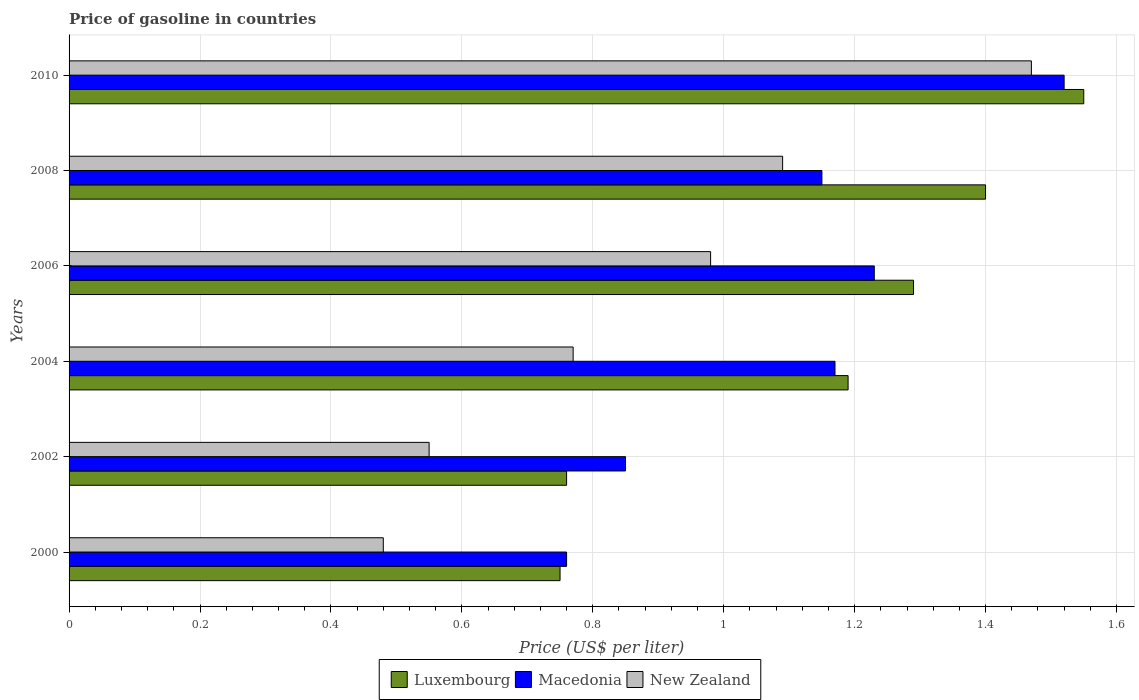How many groups of bars are there?
Ensure brevity in your answer.  6. Are the number of bars per tick equal to the number of legend labels?
Your response must be concise. Yes. Are the number of bars on each tick of the Y-axis equal?
Offer a very short reply. Yes. What is the price of gasoline in Macedonia in 2008?
Your answer should be compact. 1.15. Across all years, what is the maximum price of gasoline in Luxembourg?
Your answer should be compact. 1.55. Across all years, what is the minimum price of gasoline in New Zealand?
Your response must be concise. 0.48. What is the total price of gasoline in Luxembourg in the graph?
Ensure brevity in your answer.  6.94. What is the difference between the price of gasoline in New Zealand in 2002 and that in 2010?
Make the answer very short. -0.92. What is the difference between the price of gasoline in Macedonia in 2008 and the price of gasoline in Luxembourg in 2002?
Provide a succinct answer. 0.39. What is the average price of gasoline in New Zealand per year?
Provide a succinct answer. 0.89. In the year 2008, what is the difference between the price of gasoline in New Zealand and price of gasoline in Macedonia?
Your response must be concise. -0.06. In how many years, is the price of gasoline in Macedonia greater than 0.28 US$?
Provide a short and direct response. 6. What is the ratio of the price of gasoline in New Zealand in 2002 to that in 2008?
Offer a terse response. 0.5. Is the difference between the price of gasoline in New Zealand in 2002 and 2008 greater than the difference between the price of gasoline in Macedonia in 2002 and 2008?
Offer a terse response. No. What is the difference between the highest and the second highest price of gasoline in Macedonia?
Offer a terse response. 0.29. In how many years, is the price of gasoline in New Zealand greater than the average price of gasoline in New Zealand taken over all years?
Provide a short and direct response. 3. What does the 1st bar from the top in 2002 represents?
Ensure brevity in your answer.  New Zealand. What does the 3rd bar from the bottom in 2002 represents?
Your response must be concise. New Zealand. How many bars are there?
Ensure brevity in your answer.  18. Are all the bars in the graph horizontal?
Ensure brevity in your answer.  Yes. How many years are there in the graph?
Ensure brevity in your answer.  6. What is the difference between two consecutive major ticks on the X-axis?
Give a very brief answer. 0.2. Are the values on the major ticks of X-axis written in scientific E-notation?
Keep it short and to the point. No. How are the legend labels stacked?
Your response must be concise. Horizontal. What is the title of the graph?
Offer a very short reply. Price of gasoline in countries. What is the label or title of the X-axis?
Your answer should be very brief. Price (US$ per liter). What is the label or title of the Y-axis?
Keep it short and to the point. Years. What is the Price (US$ per liter) of Luxembourg in 2000?
Provide a short and direct response. 0.75. What is the Price (US$ per liter) of Macedonia in 2000?
Provide a succinct answer. 0.76. What is the Price (US$ per liter) in New Zealand in 2000?
Provide a short and direct response. 0.48. What is the Price (US$ per liter) of Luxembourg in 2002?
Keep it short and to the point. 0.76. What is the Price (US$ per liter) of Macedonia in 2002?
Your answer should be very brief. 0.85. What is the Price (US$ per liter) in New Zealand in 2002?
Your answer should be very brief. 0.55. What is the Price (US$ per liter) of Luxembourg in 2004?
Offer a very short reply. 1.19. What is the Price (US$ per liter) of Macedonia in 2004?
Make the answer very short. 1.17. What is the Price (US$ per liter) of New Zealand in 2004?
Ensure brevity in your answer.  0.77. What is the Price (US$ per liter) of Luxembourg in 2006?
Provide a succinct answer. 1.29. What is the Price (US$ per liter) in Macedonia in 2006?
Give a very brief answer. 1.23. What is the Price (US$ per liter) of New Zealand in 2006?
Give a very brief answer. 0.98. What is the Price (US$ per liter) in Macedonia in 2008?
Give a very brief answer. 1.15. What is the Price (US$ per liter) in New Zealand in 2008?
Ensure brevity in your answer.  1.09. What is the Price (US$ per liter) of Luxembourg in 2010?
Make the answer very short. 1.55. What is the Price (US$ per liter) of Macedonia in 2010?
Your response must be concise. 1.52. What is the Price (US$ per liter) in New Zealand in 2010?
Keep it short and to the point. 1.47. Across all years, what is the maximum Price (US$ per liter) of Luxembourg?
Your response must be concise. 1.55. Across all years, what is the maximum Price (US$ per liter) in Macedonia?
Offer a very short reply. 1.52. Across all years, what is the maximum Price (US$ per liter) of New Zealand?
Your answer should be compact. 1.47. Across all years, what is the minimum Price (US$ per liter) of Luxembourg?
Offer a terse response. 0.75. Across all years, what is the minimum Price (US$ per liter) of Macedonia?
Your answer should be compact. 0.76. Across all years, what is the minimum Price (US$ per liter) of New Zealand?
Provide a short and direct response. 0.48. What is the total Price (US$ per liter) in Luxembourg in the graph?
Keep it short and to the point. 6.94. What is the total Price (US$ per liter) in Macedonia in the graph?
Your answer should be very brief. 6.68. What is the total Price (US$ per liter) in New Zealand in the graph?
Your response must be concise. 5.34. What is the difference between the Price (US$ per liter) of Luxembourg in 2000 and that in 2002?
Give a very brief answer. -0.01. What is the difference between the Price (US$ per liter) of Macedonia in 2000 and that in 2002?
Provide a succinct answer. -0.09. What is the difference between the Price (US$ per liter) of New Zealand in 2000 and that in 2002?
Your answer should be compact. -0.07. What is the difference between the Price (US$ per liter) of Luxembourg in 2000 and that in 2004?
Your answer should be compact. -0.44. What is the difference between the Price (US$ per liter) of Macedonia in 2000 and that in 2004?
Provide a short and direct response. -0.41. What is the difference between the Price (US$ per liter) of New Zealand in 2000 and that in 2004?
Your answer should be very brief. -0.29. What is the difference between the Price (US$ per liter) of Luxembourg in 2000 and that in 2006?
Provide a short and direct response. -0.54. What is the difference between the Price (US$ per liter) in Macedonia in 2000 and that in 2006?
Your answer should be compact. -0.47. What is the difference between the Price (US$ per liter) of New Zealand in 2000 and that in 2006?
Offer a very short reply. -0.5. What is the difference between the Price (US$ per liter) of Luxembourg in 2000 and that in 2008?
Your response must be concise. -0.65. What is the difference between the Price (US$ per liter) in Macedonia in 2000 and that in 2008?
Your answer should be very brief. -0.39. What is the difference between the Price (US$ per liter) in New Zealand in 2000 and that in 2008?
Provide a succinct answer. -0.61. What is the difference between the Price (US$ per liter) of Macedonia in 2000 and that in 2010?
Make the answer very short. -0.76. What is the difference between the Price (US$ per liter) of New Zealand in 2000 and that in 2010?
Offer a terse response. -0.99. What is the difference between the Price (US$ per liter) of Luxembourg in 2002 and that in 2004?
Make the answer very short. -0.43. What is the difference between the Price (US$ per liter) of Macedonia in 2002 and that in 2004?
Keep it short and to the point. -0.32. What is the difference between the Price (US$ per liter) in New Zealand in 2002 and that in 2004?
Keep it short and to the point. -0.22. What is the difference between the Price (US$ per liter) in Luxembourg in 2002 and that in 2006?
Your response must be concise. -0.53. What is the difference between the Price (US$ per liter) in Macedonia in 2002 and that in 2006?
Give a very brief answer. -0.38. What is the difference between the Price (US$ per liter) of New Zealand in 2002 and that in 2006?
Offer a terse response. -0.43. What is the difference between the Price (US$ per liter) in Luxembourg in 2002 and that in 2008?
Offer a terse response. -0.64. What is the difference between the Price (US$ per liter) of Macedonia in 2002 and that in 2008?
Offer a terse response. -0.3. What is the difference between the Price (US$ per liter) in New Zealand in 2002 and that in 2008?
Provide a short and direct response. -0.54. What is the difference between the Price (US$ per liter) of Luxembourg in 2002 and that in 2010?
Your answer should be very brief. -0.79. What is the difference between the Price (US$ per liter) of Macedonia in 2002 and that in 2010?
Provide a short and direct response. -0.67. What is the difference between the Price (US$ per liter) in New Zealand in 2002 and that in 2010?
Your response must be concise. -0.92. What is the difference between the Price (US$ per liter) in Luxembourg in 2004 and that in 2006?
Give a very brief answer. -0.1. What is the difference between the Price (US$ per liter) of Macedonia in 2004 and that in 2006?
Your response must be concise. -0.06. What is the difference between the Price (US$ per liter) of New Zealand in 2004 and that in 2006?
Your response must be concise. -0.21. What is the difference between the Price (US$ per liter) in Luxembourg in 2004 and that in 2008?
Your response must be concise. -0.21. What is the difference between the Price (US$ per liter) of New Zealand in 2004 and that in 2008?
Your answer should be compact. -0.32. What is the difference between the Price (US$ per liter) in Luxembourg in 2004 and that in 2010?
Provide a short and direct response. -0.36. What is the difference between the Price (US$ per liter) of Macedonia in 2004 and that in 2010?
Provide a short and direct response. -0.35. What is the difference between the Price (US$ per liter) of New Zealand in 2004 and that in 2010?
Your answer should be compact. -0.7. What is the difference between the Price (US$ per liter) of Luxembourg in 2006 and that in 2008?
Offer a terse response. -0.11. What is the difference between the Price (US$ per liter) in New Zealand in 2006 and that in 2008?
Offer a very short reply. -0.11. What is the difference between the Price (US$ per liter) of Luxembourg in 2006 and that in 2010?
Your answer should be very brief. -0.26. What is the difference between the Price (US$ per liter) of Macedonia in 2006 and that in 2010?
Your answer should be very brief. -0.29. What is the difference between the Price (US$ per liter) of New Zealand in 2006 and that in 2010?
Offer a terse response. -0.49. What is the difference between the Price (US$ per liter) in Macedonia in 2008 and that in 2010?
Offer a very short reply. -0.37. What is the difference between the Price (US$ per liter) in New Zealand in 2008 and that in 2010?
Your answer should be very brief. -0.38. What is the difference between the Price (US$ per liter) in Luxembourg in 2000 and the Price (US$ per liter) in Macedonia in 2002?
Give a very brief answer. -0.1. What is the difference between the Price (US$ per liter) of Macedonia in 2000 and the Price (US$ per liter) of New Zealand in 2002?
Provide a succinct answer. 0.21. What is the difference between the Price (US$ per liter) in Luxembourg in 2000 and the Price (US$ per liter) in Macedonia in 2004?
Provide a succinct answer. -0.42. What is the difference between the Price (US$ per liter) of Luxembourg in 2000 and the Price (US$ per liter) of New Zealand in 2004?
Provide a short and direct response. -0.02. What is the difference between the Price (US$ per liter) in Macedonia in 2000 and the Price (US$ per liter) in New Zealand in 2004?
Your response must be concise. -0.01. What is the difference between the Price (US$ per liter) in Luxembourg in 2000 and the Price (US$ per liter) in Macedonia in 2006?
Offer a very short reply. -0.48. What is the difference between the Price (US$ per liter) of Luxembourg in 2000 and the Price (US$ per liter) of New Zealand in 2006?
Make the answer very short. -0.23. What is the difference between the Price (US$ per liter) in Macedonia in 2000 and the Price (US$ per liter) in New Zealand in 2006?
Give a very brief answer. -0.22. What is the difference between the Price (US$ per liter) in Luxembourg in 2000 and the Price (US$ per liter) in Macedonia in 2008?
Give a very brief answer. -0.4. What is the difference between the Price (US$ per liter) of Luxembourg in 2000 and the Price (US$ per liter) of New Zealand in 2008?
Your response must be concise. -0.34. What is the difference between the Price (US$ per liter) of Macedonia in 2000 and the Price (US$ per liter) of New Zealand in 2008?
Make the answer very short. -0.33. What is the difference between the Price (US$ per liter) in Luxembourg in 2000 and the Price (US$ per liter) in Macedonia in 2010?
Your answer should be very brief. -0.77. What is the difference between the Price (US$ per liter) in Luxembourg in 2000 and the Price (US$ per liter) in New Zealand in 2010?
Your answer should be compact. -0.72. What is the difference between the Price (US$ per liter) of Macedonia in 2000 and the Price (US$ per liter) of New Zealand in 2010?
Offer a terse response. -0.71. What is the difference between the Price (US$ per liter) in Luxembourg in 2002 and the Price (US$ per liter) in Macedonia in 2004?
Offer a terse response. -0.41. What is the difference between the Price (US$ per liter) in Luxembourg in 2002 and the Price (US$ per liter) in New Zealand in 2004?
Offer a very short reply. -0.01. What is the difference between the Price (US$ per liter) in Macedonia in 2002 and the Price (US$ per liter) in New Zealand in 2004?
Your answer should be compact. 0.08. What is the difference between the Price (US$ per liter) in Luxembourg in 2002 and the Price (US$ per liter) in Macedonia in 2006?
Offer a very short reply. -0.47. What is the difference between the Price (US$ per liter) in Luxembourg in 2002 and the Price (US$ per liter) in New Zealand in 2006?
Give a very brief answer. -0.22. What is the difference between the Price (US$ per liter) of Macedonia in 2002 and the Price (US$ per liter) of New Zealand in 2006?
Provide a short and direct response. -0.13. What is the difference between the Price (US$ per liter) in Luxembourg in 2002 and the Price (US$ per liter) in Macedonia in 2008?
Offer a very short reply. -0.39. What is the difference between the Price (US$ per liter) of Luxembourg in 2002 and the Price (US$ per liter) of New Zealand in 2008?
Ensure brevity in your answer.  -0.33. What is the difference between the Price (US$ per liter) of Macedonia in 2002 and the Price (US$ per liter) of New Zealand in 2008?
Give a very brief answer. -0.24. What is the difference between the Price (US$ per liter) in Luxembourg in 2002 and the Price (US$ per liter) in Macedonia in 2010?
Ensure brevity in your answer.  -0.76. What is the difference between the Price (US$ per liter) of Luxembourg in 2002 and the Price (US$ per liter) of New Zealand in 2010?
Your response must be concise. -0.71. What is the difference between the Price (US$ per liter) in Macedonia in 2002 and the Price (US$ per liter) in New Zealand in 2010?
Offer a terse response. -0.62. What is the difference between the Price (US$ per liter) in Luxembourg in 2004 and the Price (US$ per liter) in Macedonia in 2006?
Offer a terse response. -0.04. What is the difference between the Price (US$ per liter) in Luxembourg in 2004 and the Price (US$ per liter) in New Zealand in 2006?
Your answer should be very brief. 0.21. What is the difference between the Price (US$ per liter) in Macedonia in 2004 and the Price (US$ per liter) in New Zealand in 2006?
Ensure brevity in your answer.  0.19. What is the difference between the Price (US$ per liter) in Luxembourg in 2004 and the Price (US$ per liter) in Macedonia in 2008?
Keep it short and to the point. 0.04. What is the difference between the Price (US$ per liter) of Luxembourg in 2004 and the Price (US$ per liter) of New Zealand in 2008?
Offer a terse response. 0.1. What is the difference between the Price (US$ per liter) in Luxembourg in 2004 and the Price (US$ per liter) in Macedonia in 2010?
Your answer should be compact. -0.33. What is the difference between the Price (US$ per liter) in Luxembourg in 2004 and the Price (US$ per liter) in New Zealand in 2010?
Ensure brevity in your answer.  -0.28. What is the difference between the Price (US$ per liter) of Macedonia in 2004 and the Price (US$ per liter) of New Zealand in 2010?
Provide a short and direct response. -0.3. What is the difference between the Price (US$ per liter) in Luxembourg in 2006 and the Price (US$ per liter) in Macedonia in 2008?
Keep it short and to the point. 0.14. What is the difference between the Price (US$ per liter) in Macedonia in 2006 and the Price (US$ per liter) in New Zealand in 2008?
Your response must be concise. 0.14. What is the difference between the Price (US$ per liter) in Luxembourg in 2006 and the Price (US$ per liter) in Macedonia in 2010?
Ensure brevity in your answer.  -0.23. What is the difference between the Price (US$ per liter) of Luxembourg in 2006 and the Price (US$ per liter) of New Zealand in 2010?
Your answer should be very brief. -0.18. What is the difference between the Price (US$ per liter) of Macedonia in 2006 and the Price (US$ per liter) of New Zealand in 2010?
Offer a very short reply. -0.24. What is the difference between the Price (US$ per liter) of Luxembourg in 2008 and the Price (US$ per liter) of Macedonia in 2010?
Make the answer very short. -0.12. What is the difference between the Price (US$ per liter) of Luxembourg in 2008 and the Price (US$ per liter) of New Zealand in 2010?
Provide a short and direct response. -0.07. What is the difference between the Price (US$ per liter) of Macedonia in 2008 and the Price (US$ per liter) of New Zealand in 2010?
Provide a short and direct response. -0.32. What is the average Price (US$ per liter) in Luxembourg per year?
Your response must be concise. 1.16. What is the average Price (US$ per liter) of Macedonia per year?
Give a very brief answer. 1.11. What is the average Price (US$ per liter) of New Zealand per year?
Offer a terse response. 0.89. In the year 2000, what is the difference between the Price (US$ per liter) in Luxembourg and Price (US$ per liter) in Macedonia?
Offer a very short reply. -0.01. In the year 2000, what is the difference between the Price (US$ per liter) in Luxembourg and Price (US$ per liter) in New Zealand?
Give a very brief answer. 0.27. In the year 2000, what is the difference between the Price (US$ per liter) in Macedonia and Price (US$ per liter) in New Zealand?
Keep it short and to the point. 0.28. In the year 2002, what is the difference between the Price (US$ per liter) of Luxembourg and Price (US$ per liter) of Macedonia?
Your response must be concise. -0.09. In the year 2002, what is the difference between the Price (US$ per liter) in Luxembourg and Price (US$ per liter) in New Zealand?
Your answer should be compact. 0.21. In the year 2004, what is the difference between the Price (US$ per liter) in Luxembourg and Price (US$ per liter) in Macedonia?
Make the answer very short. 0.02. In the year 2004, what is the difference between the Price (US$ per liter) of Luxembourg and Price (US$ per liter) of New Zealand?
Your answer should be compact. 0.42. In the year 2006, what is the difference between the Price (US$ per liter) in Luxembourg and Price (US$ per liter) in Macedonia?
Your answer should be compact. 0.06. In the year 2006, what is the difference between the Price (US$ per liter) of Luxembourg and Price (US$ per liter) of New Zealand?
Your answer should be very brief. 0.31. In the year 2006, what is the difference between the Price (US$ per liter) of Macedonia and Price (US$ per liter) of New Zealand?
Your answer should be very brief. 0.25. In the year 2008, what is the difference between the Price (US$ per liter) in Luxembourg and Price (US$ per liter) in Macedonia?
Give a very brief answer. 0.25. In the year 2008, what is the difference between the Price (US$ per liter) of Luxembourg and Price (US$ per liter) of New Zealand?
Your answer should be very brief. 0.31. In the year 2008, what is the difference between the Price (US$ per liter) of Macedonia and Price (US$ per liter) of New Zealand?
Your answer should be compact. 0.06. In the year 2010, what is the difference between the Price (US$ per liter) in Luxembourg and Price (US$ per liter) in Macedonia?
Provide a short and direct response. 0.03. In the year 2010, what is the difference between the Price (US$ per liter) in Macedonia and Price (US$ per liter) in New Zealand?
Ensure brevity in your answer.  0.05. What is the ratio of the Price (US$ per liter) in Luxembourg in 2000 to that in 2002?
Your answer should be very brief. 0.99. What is the ratio of the Price (US$ per liter) of Macedonia in 2000 to that in 2002?
Offer a terse response. 0.89. What is the ratio of the Price (US$ per liter) of New Zealand in 2000 to that in 2002?
Ensure brevity in your answer.  0.87. What is the ratio of the Price (US$ per liter) in Luxembourg in 2000 to that in 2004?
Keep it short and to the point. 0.63. What is the ratio of the Price (US$ per liter) of Macedonia in 2000 to that in 2004?
Offer a terse response. 0.65. What is the ratio of the Price (US$ per liter) of New Zealand in 2000 to that in 2004?
Provide a short and direct response. 0.62. What is the ratio of the Price (US$ per liter) in Luxembourg in 2000 to that in 2006?
Keep it short and to the point. 0.58. What is the ratio of the Price (US$ per liter) in Macedonia in 2000 to that in 2006?
Make the answer very short. 0.62. What is the ratio of the Price (US$ per liter) of New Zealand in 2000 to that in 2006?
Provide a succinct answer. 0.49. What is the ratio of the Price (US$ per liter) of Luxembourg in 2000 to that in 2008?
Provide a short and direct response. 0.54. What is the ratio of the Price (US$ per liter) in Macedonia in 2000 to that in 2008?
Offer a very short reply. 0.66. What is the ratio of the Price (US$ per liter) in New Zealand in 2000 to that in 2008?
Your answer should be very brief. 0.44. What is the ratio of the Price (US$ per liter) in Luxembourg in 2000 to that in 2010?
Your response must be concise. 0.48. What is the ratio of the Price (US$ per liter) in New Zealand in 2000 to that in 2010?
Give a very brief answer. 0.33. What is the ratio of the Price (US$ per liter) in Luxembourg in 2002 to that in 2004?
Keep it short and to the point. 0.64. What is the ratio of the Price (US$ per liter) in Macedonia in 2002 to that in 2004?
Provide a succinct answer. 0.73. What is the ratio of the Price (US$ per liter) in Luxembourg in 2002 to that in 2006?
Make the answer very short. 0.59. What is the ratio of the Price (US$ per liter) of Macedonia in 2002 to that in 2006?
Offer a terse response. 0.69. What is the ratio of the Price (US$ per liter) in New Zealand in 2002 to that in 2006?
Provide a succinct answer. 0.56. What is the ratio of the Price (US$ per liter) of Luxembourg in 2002 to that in 2008?
Offer a very short reply. 0.54. What is the ratio of the Price (US$ per liter) in Macedonia in 2002 to that in 2008?
Provide a short and direct response. 0.74. What is the ratio of the Price (US$ per liter) in New Zealand in 2002 to that in 2008?
Provide a short and direct response. 0.5. What is the ratio of the Price (US$ per liter) of Luxembourg in 2002 to that in 2010?
Your answer should be very brief. 0.49. What is the ratio of the Price (US$ per liter) in Macedonia in 2002 to that in 2010?
Your response must be concise. 0.56. What is the ratio of the Price (US$ per liter) in New Zealand in 2002 to that in 2010?
Provide a succinct answer. 0.37. What is the ratio of the Price (US$ per liter) of Luxembourg in 2004 to that in 2006?
Ensure brevity in your answer.  0.92. What is the ratio of the Price (US$ per liter) of Macedonia in 2004 to that in 2006?
Give a very brief answer. 0.95. What is the ratio of the Price (US$ per liter) of New Zealand in 2004 to that in 2006?
Give a very brief answer. 0.79. What is the ratio of the Price (US$ per liter) of Macedonia in 2004 to that in 2008?
Ensure brevity in your answer.  1.02. What is the ratio of the Price (US$ per liter) in New Zealand in 2004 to that in 2008?
Ensure brevity in your answer.  0.71. What is the ratio of the Price (US$ per liter) in Luxembourg in 2004 to that in 2010?
Provide a short and direct response. 0.77. What is the ratio of the Price (US$ per liter) in Macedonia in 2004 to that in 2010?
Offer a very short reply. 0.77. What is the ratio of the Price (US$ per liter) in New Zealand in 2004 to that in 2010?
Provide a short and direct response. 0.52. What is the ratio of the Price (US$ per liter) in Luxembourg in 2006 to that in 2008?
Your answer should be very brief. 0.92. What is the ratio of the Price (US$ per liter) of Macedonia in 2006 to that in 2008?
Your answer should be very brief. 1.07. What is the ratio of the Price (US$ per liter) in New Zealand in 2006 to that in 2008?
Your answer should be very brief. 0.9. What is the ratio of the Price (US$ per liter) of Luxembourg in 2006 to that in 2010?
Make the answer very short. 0.83. What is the ratio of the Price (US$ per liter) of Macedonia in 2006 to that in 2010?
Keep it short and to the point. 0.81. What is the ratio of the Price (US$ per liter) in New Zealand in 2006 to that in 2010?
Provide a succinct answer. 0.67. What is the ratio of the Price (US$ per liter) in Luxembourg in 2008 to that in 2010?
Provide a succinct answer. 0.9. What is the ratio of the Price (US$ per liter) of Macedonia in 2008 to that in 2010?
Provide a succinct answer. 0.76. What is the ratio of the Price (US$ per liter) of New Zealand in 2008 to that in 2010?
Your answer should be compact. 0.74. What is the difference between the highest and the second highest Price (US$ per liter) in Macedonia?
Offer a very short reply. 0.29. What is the difference between the highest and the second highest Price (US$ per liter) in New Zealand?
Give a very brief answer. 0.38. What is the difference between the highest and the lowest Price (US$ per liter) in Luxembourg?
Your answer should be compact. 0.8. What is the difference between the highest and the lowest Price (US$ per liter) in Macedonia?
Offer a very short reply. 0.76. What is the difference between the highest and the lowest Price (US$ per liter) of New Zealand?
Provide a short and direct response. 0.99. 